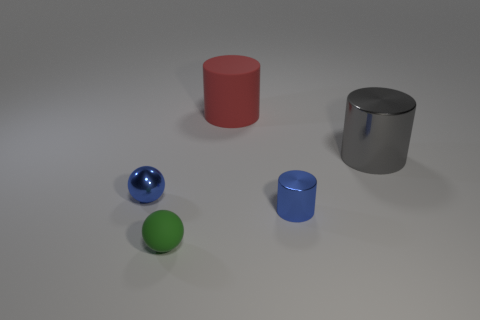What number of small gray matte spheres are there? In the image provided, there are no small gray matte spheres present. 